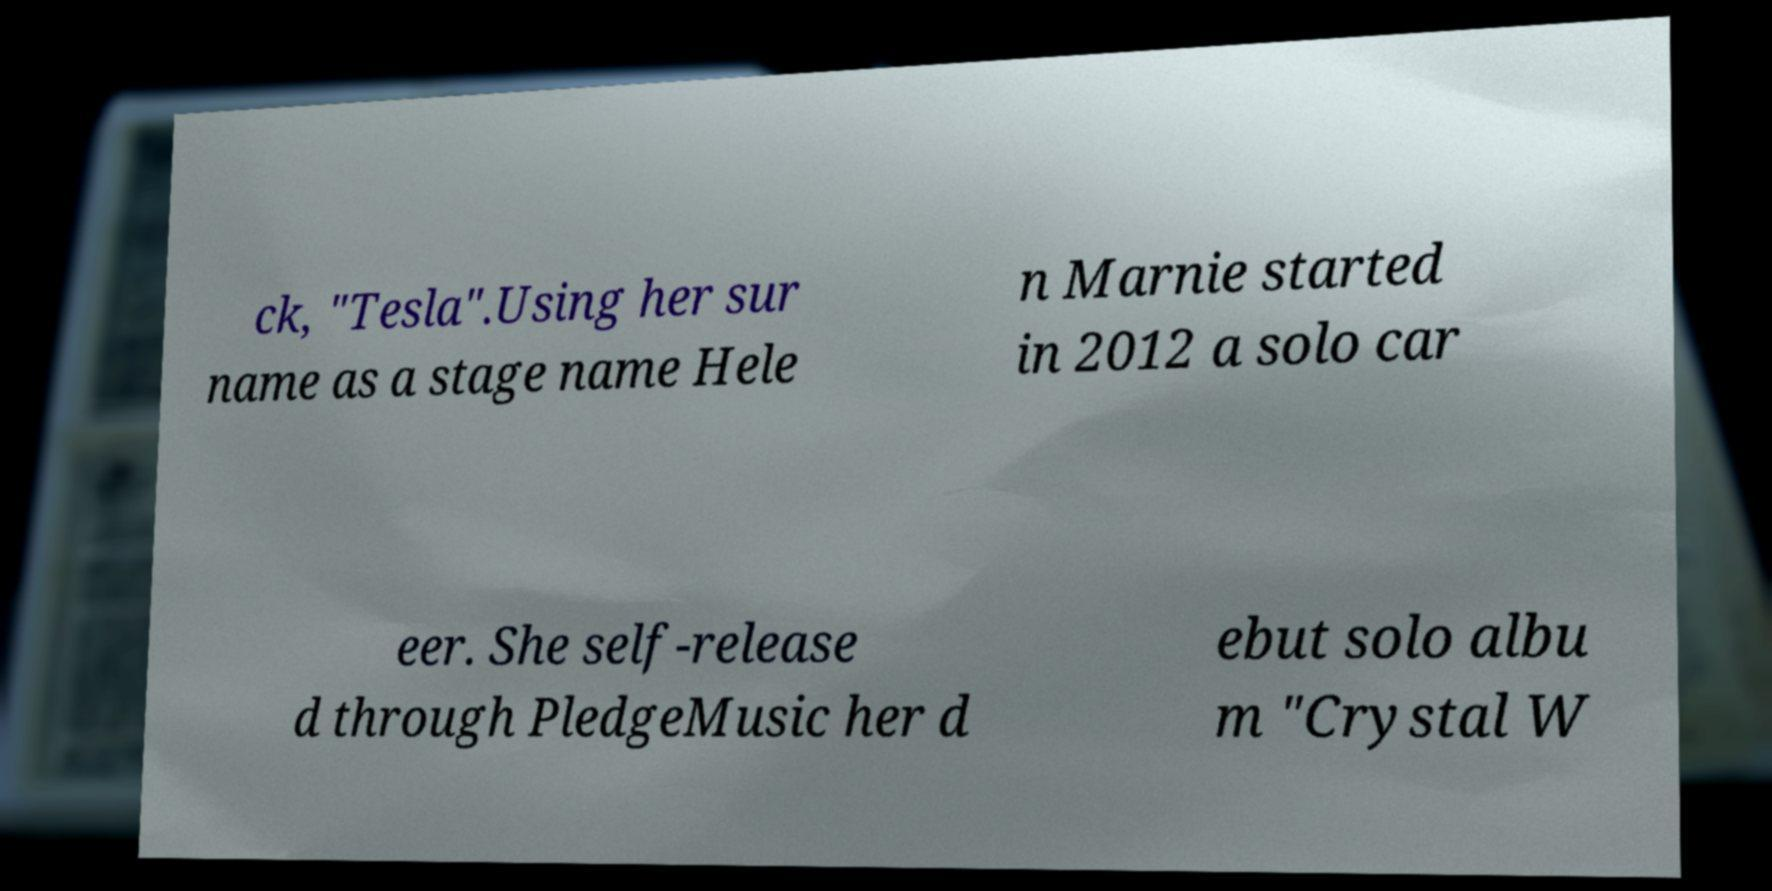For documentation purposes, I need the text within this image transcribed. Could you provide that? ck, "Tesla".Using her sur name as a stage name Hele n Marnie started in 2012 a solo car eer. She self-release d through PledgeMusic her d ebut solo albu m "Crystal W 